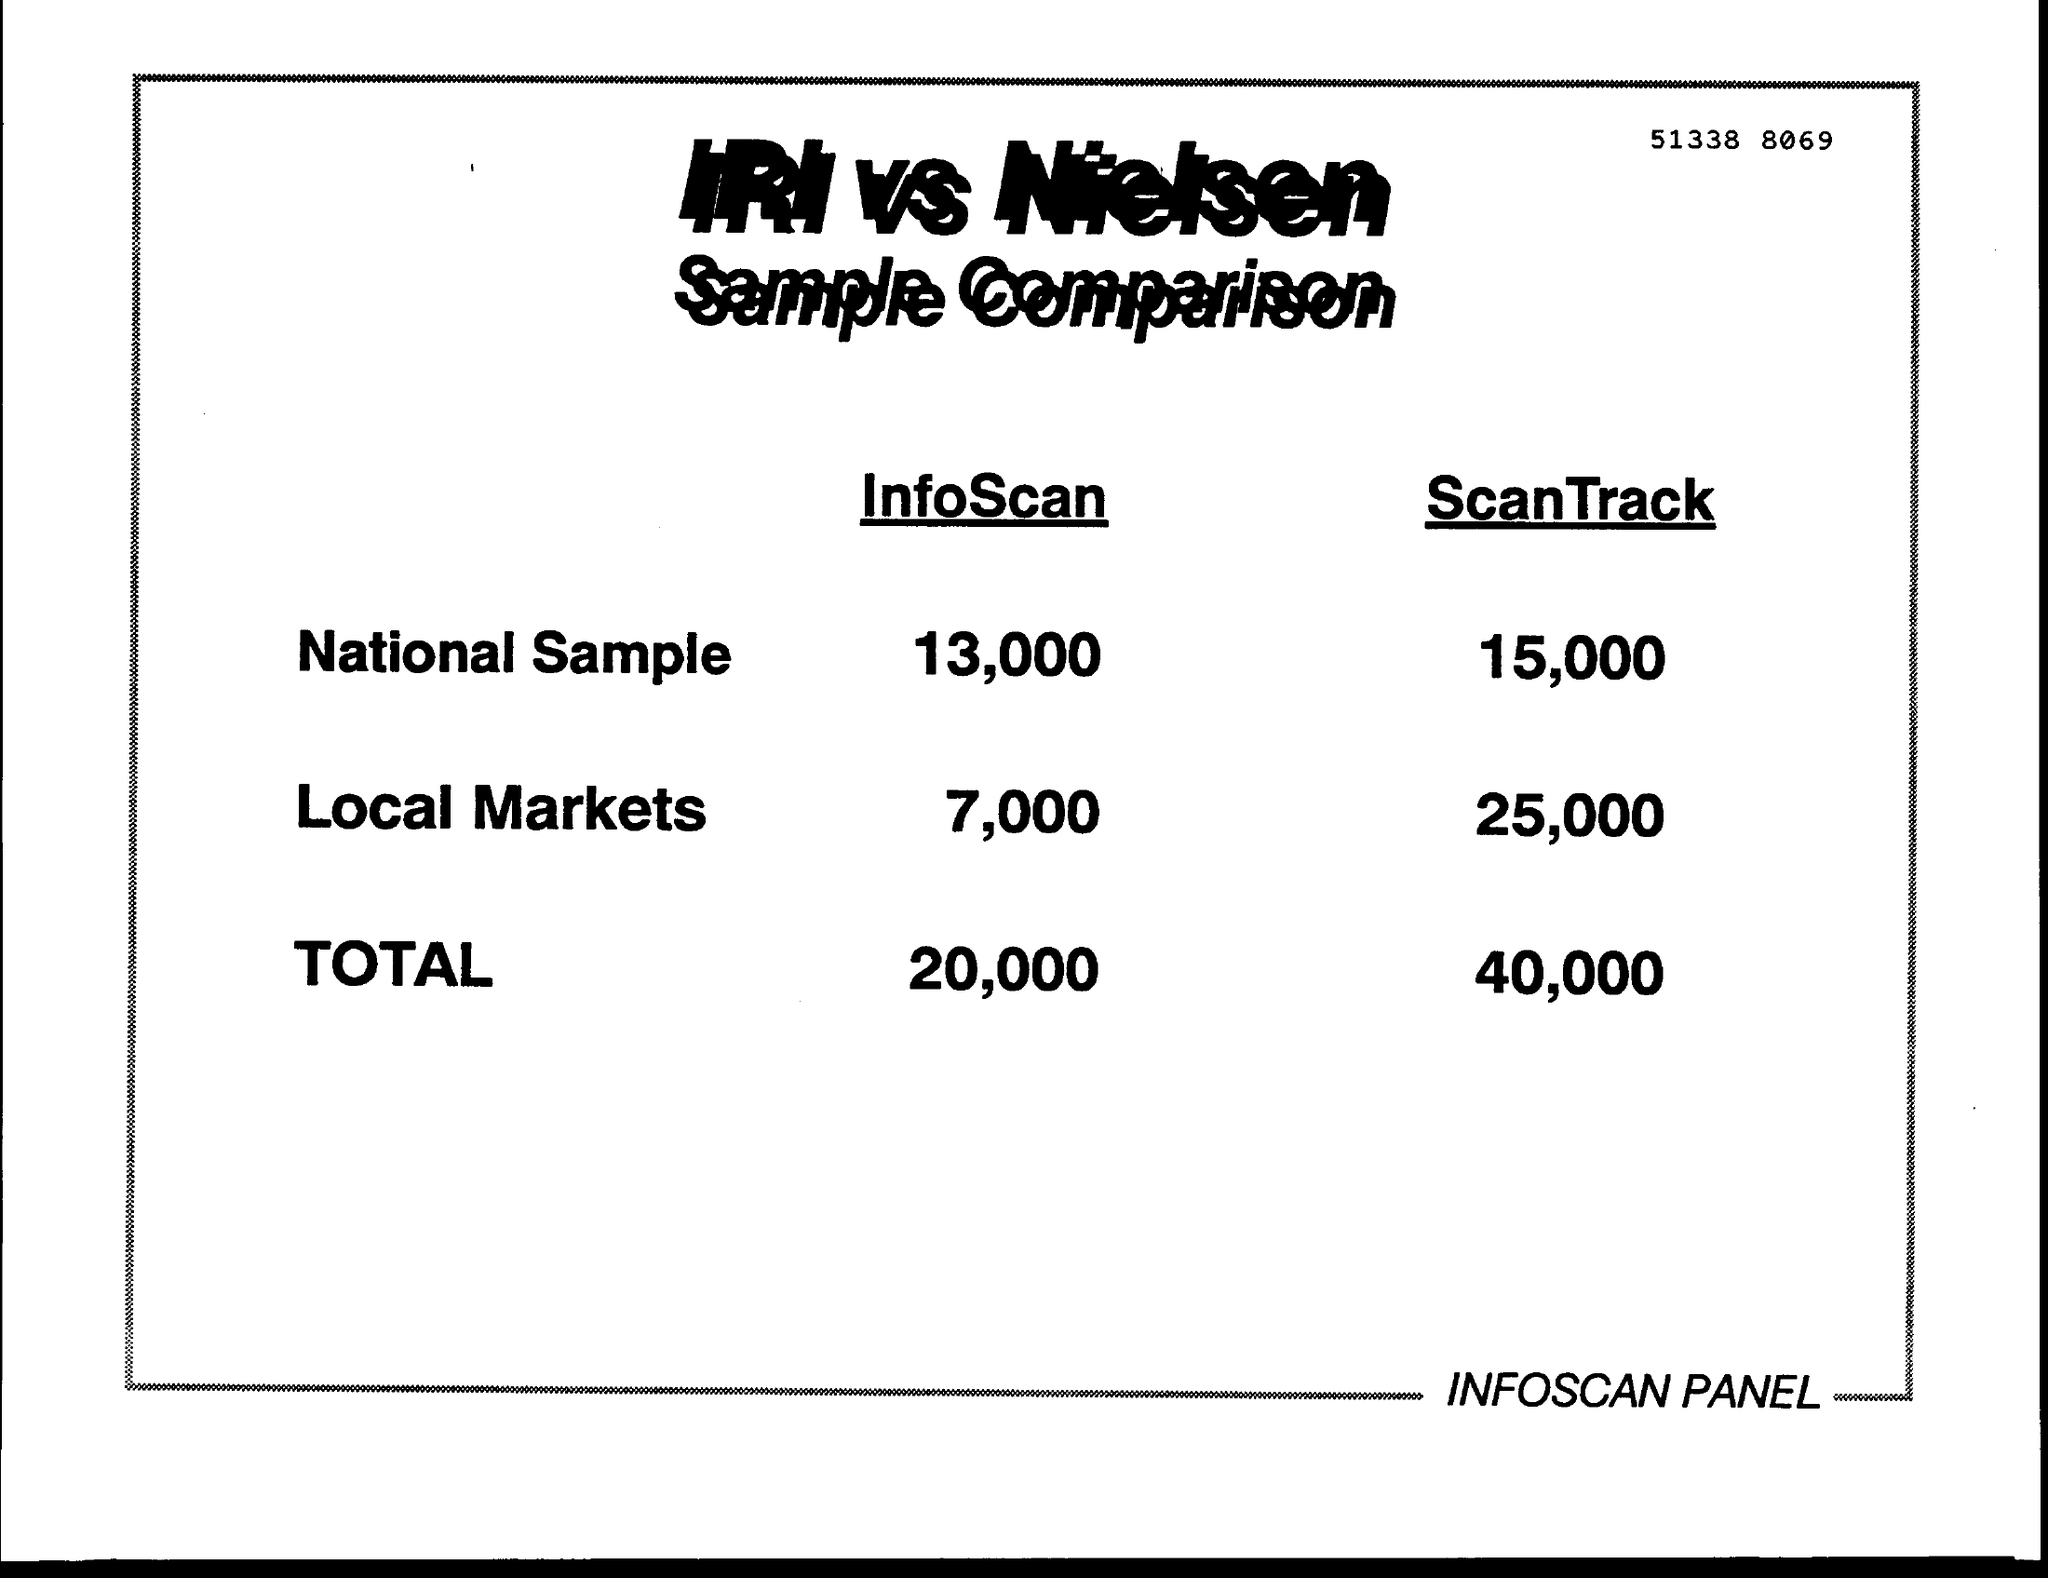List a handful of essential elements in this visual. What is the total value of ScanTrack? The total value of ScanTrack is estimated to be between 40,000 and 100,000. The number written at the top of the page is 51338 8069. The InfoScan value of the National Sample is 13,000. 